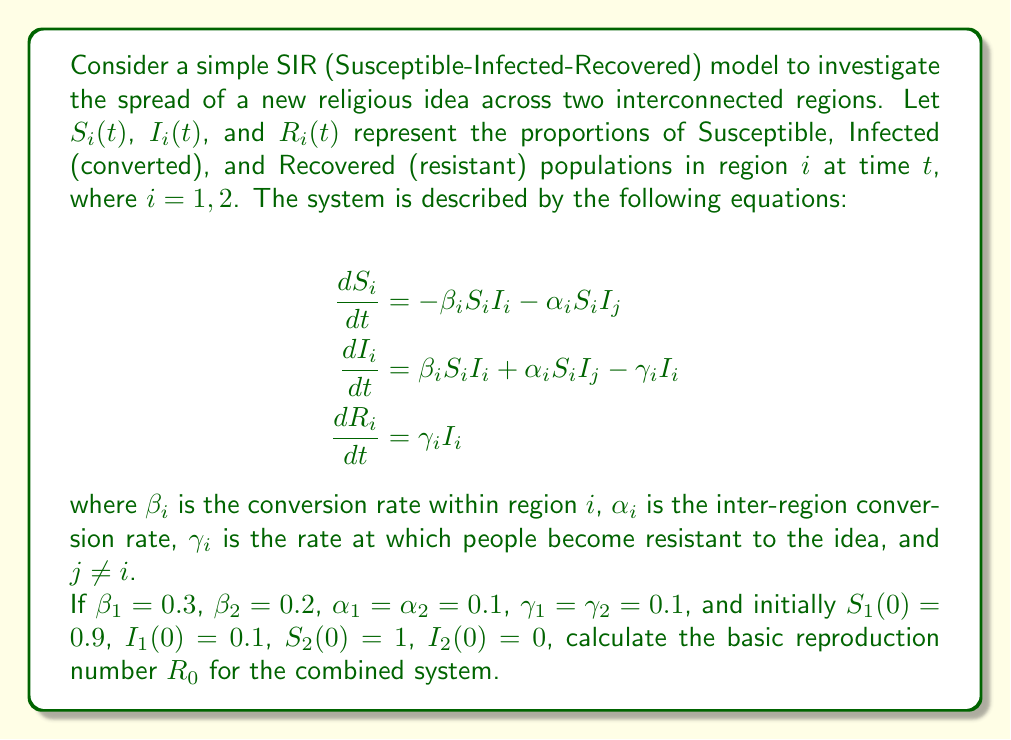What is the answer to this math problem? To solve this problem, we need to follow these steps:

1) The basic reproduction number $R_0$ for a system with multiple regions can be calculated using the next-generation matrix method.

2) First, we need to identify the infected compartments. In this case, we have $I_1$ and $I_2$.

3) We then construct the transmission matrix $T$ and the transition matrix $V$:

   $T = \begin{bmatrix} 
   \beta_1 S_1 & \alpha_1 S_1 \\
   \alpha_2 S_2 & \beta_2 S_2
   \end{bmatrix}$

   $V = \begin{bmatrix}
   \gamma_1 & 0 \\
   0 & \gamma_2
   \end{bmatrix}$

4) The next-generation matrix is given by $K = TV^{-1}$:

   $K = \begin{bmatrix} 
   \frac{\beta_1 S_1}{\gamma_1} & \frac{\alpha_1 S_1}{\gamma_2} \\
   \frac{\alpha_2 S_2}{\gamma_1} & \frac{\beta_2 S_2}{\gamma_2}
   \end{bmatrix}$

5) $R_0$ is the spectral radius (largest eigenvalue) of $K$.

6) Substituting the given values and initial conditions:

   $K = \begin{bmatrix} 
   \frac{0.3 \cdot 0.9}{0.1} & \frac{0.1 \cdot 0.9}{0.1} \\
   \frac{0.1 \cdot 1}{0.1} & \frac{0.2 \cdot 1}{0.1}
   \end{bmatrix} = \begin{bmatrix} 
   2.7 & 0.9 \\
   1 & 2
   \end{bmatrix}$

7) To find the eigenvalues, we solve the characteristic equation:

   $det(K - \lambda I) = \begin{vmatrix} 
   2.7 - \lambda & 0.9 \\
   1 & 2 - \lambda
   \end{vmatrix} = (2.7 - \lambda)(2 - \lambda) - 0.9 = 0$

8) Expanding: $\lambda^2 - 4.7\lambda + 4.5 = 0$

9) Solving this quadratic equation:

   $\lambda = \frac{4.7 \pm \sqrt{4.7^2 - 4 \cdot 4.5}}{2} = \frac{4.7 \pm \sqrt{22.09 - 18}}{2} = \frac{4.7 \pm \sqrt{4.09}}{2}$

10) The larger root is:

    $\lambda_{max} = \frac{4.7 + \sqrt{4.09}}{2} \approx 3.31$

Therefore, $R_0 \approx 3.31$.
Answer: $R_0 \approx 3.31$ 